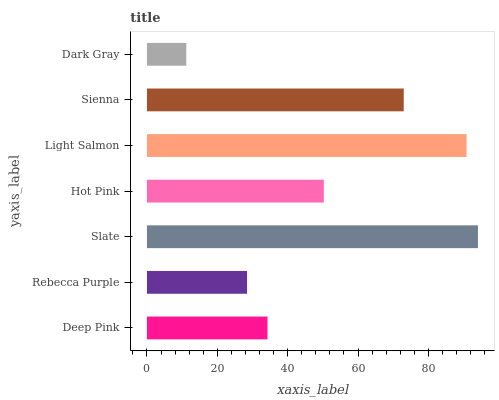Is Dark Gray the minimum?
Answer yes or no. Yes. Is Slate the maximum?
Answer yes or no. Yes. Is Rebecca Purple the minimum?
Answer yes or no. No. Is Rebecca Purple the maximum?
Answer yes or no. No. Is Deep Pink greater than Rebecca Purple?
Answer yes or no. Yes. Is Rebecca Purple less than Deep Pink?
Answer yes or no. Yes. Is Rebecca Purple greater than Deep Pink?
Answer yes or no. No. Is Deep Pink less than Rebecca Purple?
Answer yes or no. No. Is Hot Pink the high median?
Answer yes or no. Yes. Is Hot Pink the low median?
Answer yes or no. Yes. Is Light Salmon the high median?
Answer yes or no. No. Is Rebecca Purple the low median?
Answer yes or no. No. 